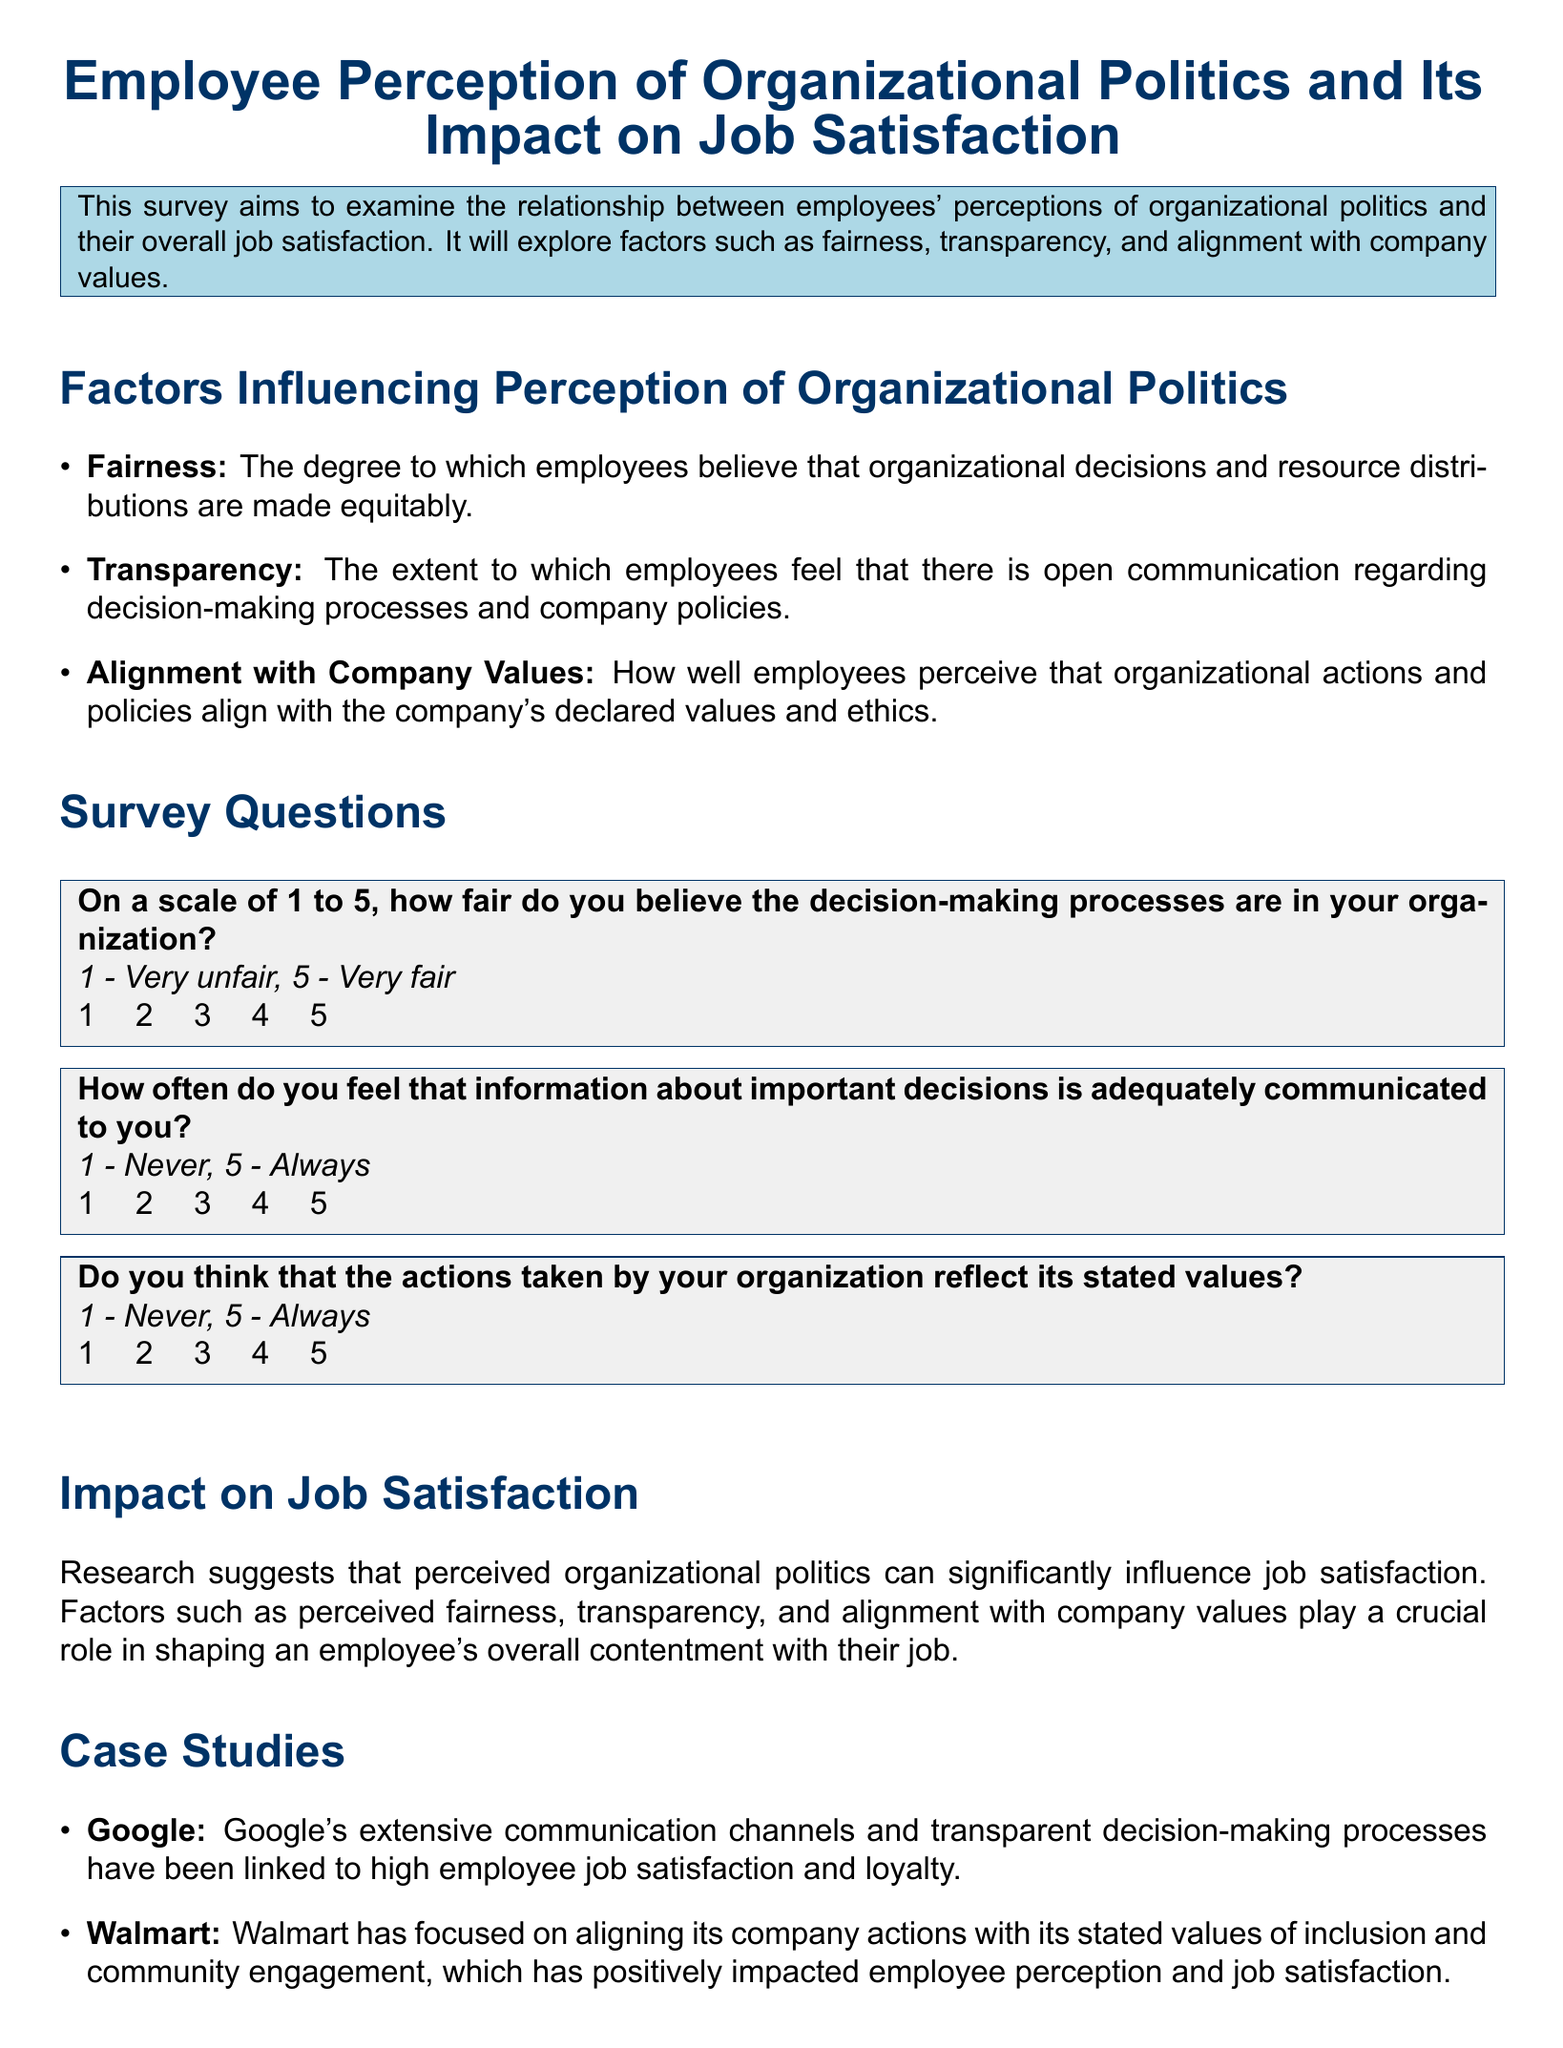What is the title of the survey? The title of the survey is clearly stated at the beginning of the document.
Answer: Employee Perception of Organizational Politics and Its Impact on Job Satisfaction What scale is used to measure fairness in decision-making processes? The document specifies that a scale from 1 to 5 is used to measure fairness.
Answer: 1 to 5 How often do respondents think important decisions are communicated? The survey question asks for respondents' frequency ratings regarding information communication.
Answer: 1 - Never, 5 - Always What is one factor influencing perception of organizational politics? The document lists factors influencing perception, and fairness is one of them.
Answer: Fairness Which company is mentioned as having transparent decision-making processes? The case study section references companies and mentions Google specifically.
Answer: Google What is suggested as essential for improving employee morale? The conclusion states key strategies for morale enhancement, indicating the importance of certain factors.
Answer: Fairness, transparency, and aligning with company values How many survey questions are included in the document? The document includes three survey questions for employee perceptions.
Answer: Three What is the main focus of the survey? The purpose of the survey is summarized in the introduction section.
Answer: Employee perceptions of organizational politics and job satisfaction What color scheme is used in the document's header section? The title format includes specific color definitions that apply to the header.
Answer: Dark blue and light gray 